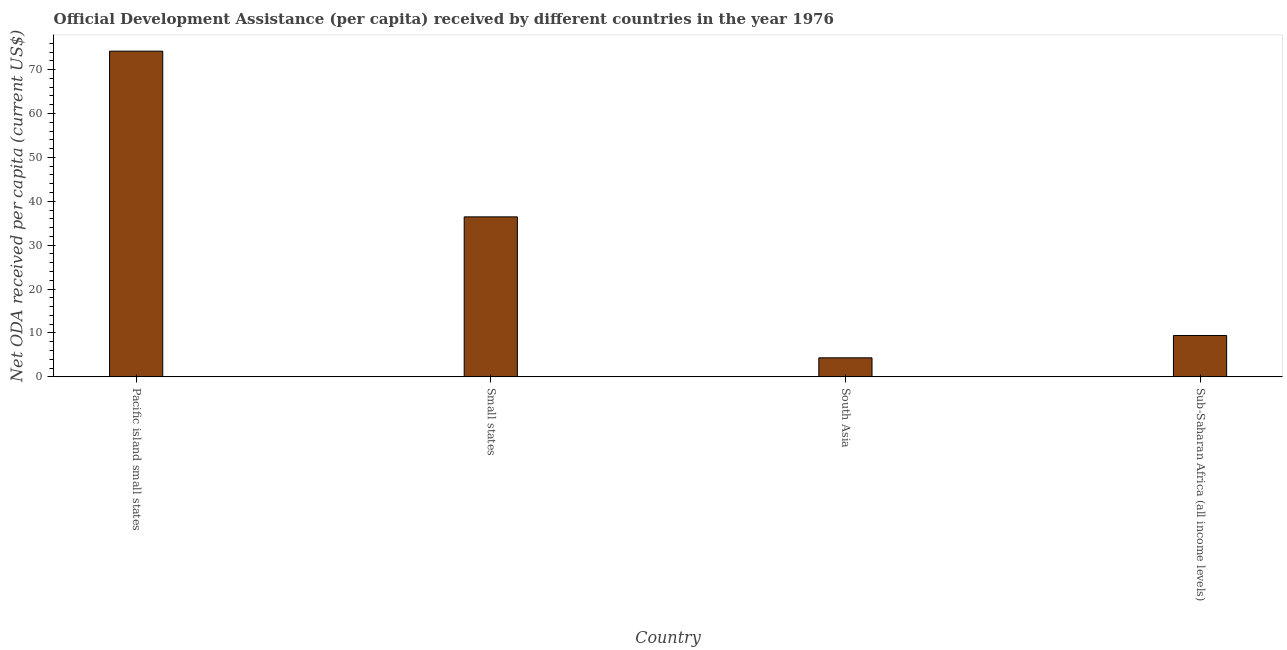What is the title of the graph?
Your answer should be very brief. Official Development Assistance (per capita) received by different countries in the year 1976. What is the label or title of the X-axis?
Your response must be concise. Country. What is the label or title of the Y-axis?
Provide a short and direct response. Net ODA received per capita (current US$). What is the net oda received per capita in Sub-Saharan Africa (all income levels)?
Make the answer very short. 9.42. Across all countries, what is the maximum net oda received per capita?
Keep it short and to the point. 74.21. Across all countries, what is the minimum net oda received per capita?
Keep it short and to the point. 4.34. In which country was the net oda received per capita maximum?
Your response must be concise. Pacific island small states. In which country was the net oda received per capita minimum?
Your answer should be very brief. South Asia. What is the sum of the net oda received per capita?
Make the answer very short. 124.43. What is the difference between the net oda received per capita in Pacific island small states and South Asia?
Provide a succinct answer. 69.88. What is the average net oda received per capita per country?
Provide a succinct answer. 31.11. What is the median net oda received per capita?
Provide a succinct answer. 22.94. What is the ratio of the net oda received per capita in Small states to that in South Asia?
Make the answer very short. 8.41. Is the net oda received per capita in Pacific island small states less than that in Sub-Saharan Africa (all income levels)?
Keep it short and to the point. No. What is the difference between the highest and the second highest net oda received per capita?
Your answer should be compact. 37.76. What is the difference between the highest and the lowest net oda received per capita?
Give a very brief answer. 69.88. How many countries are there in the graph?
Ensure brevity in your answer.  4. What is the difference between two consecutive major ticks on the Y-axis?
Your answer should be very brief. 10. Are the values on the major ticks of Y-axis written in scientific E-notation?
Provide a succinct answer. No. What is the Net ODA received per capita (current US$) of Pacific island small states?
Offer a very short reply. 74.21. What is the Net ODA received per capita (current US$) of Small states?
Keep it short and to the point. 36.46. What is the Net ODA received per capita (current US$) in South Asia?
Give a very brief answer. 4.34. What is the Net ODA received per capita (current US$) in Sub-Saharan Africa (all income levels)?
Ensure brevity in your answer.  9.42. What is the difference between the Net ODA received per capita (current US$) in Pacific island small states and Small states?
Your answer should be compact. 37.76. What is the difference between the Net ODA received per capita (current US$) in Pacific island small states and South Asia?
Your response must be concise. 69.88. What is the difference between the Net ODA received per capita (current US$) in Pacific island small states and Sub-Saharan Africa (all income levels)?
Your answer should be very brief. 64.79. What is the difference between the Net ODA received per capita (current US$) in Small states and South Asia?
Ensure brevity in your answer.  32.12. What is the difference between the Net ODA received per capita (current US$) in Small states and Sub-Saharan Africa (all income levels)?
Your response must be concise. 27.03. What is the difference between the Net ODA received per capita (current US$) in South Asia and Sub-Saharan Africa (all income levels)?
Your response must be concise. -5.09. What is the ratio of the Net ODA received per capita (current US$) in Pacific island small states to that in Small states?
Offer a terse response. 2.04. What is the ratio of the Net ODA received per capita (current US$) in Pacific island small states to that in South Asia?
Offer a very short reply. 17.12. What is the ratio of the Net ODA received per capita (current US$) in Pacific island small states to that in Sub-Saharan Africa (all income levels)?
Your answer should be compact. 7.88. What is the ratio of the Net ODA received per capita (current US$) in Small states to that in South Asia?
Your response must be concise. 8.41. What is the ratio of the Net ODA received per capita (current US$) in Small states to that in Sub-Saharan Africa (all income levels)?
Your response must be concise. 3.87. What is the ratio of the Net ODA received per capita (current US$) in South Asia to that in Sub-Saharan Africa (all income levels)?
Ensure brevity in your answer.  0.46. 